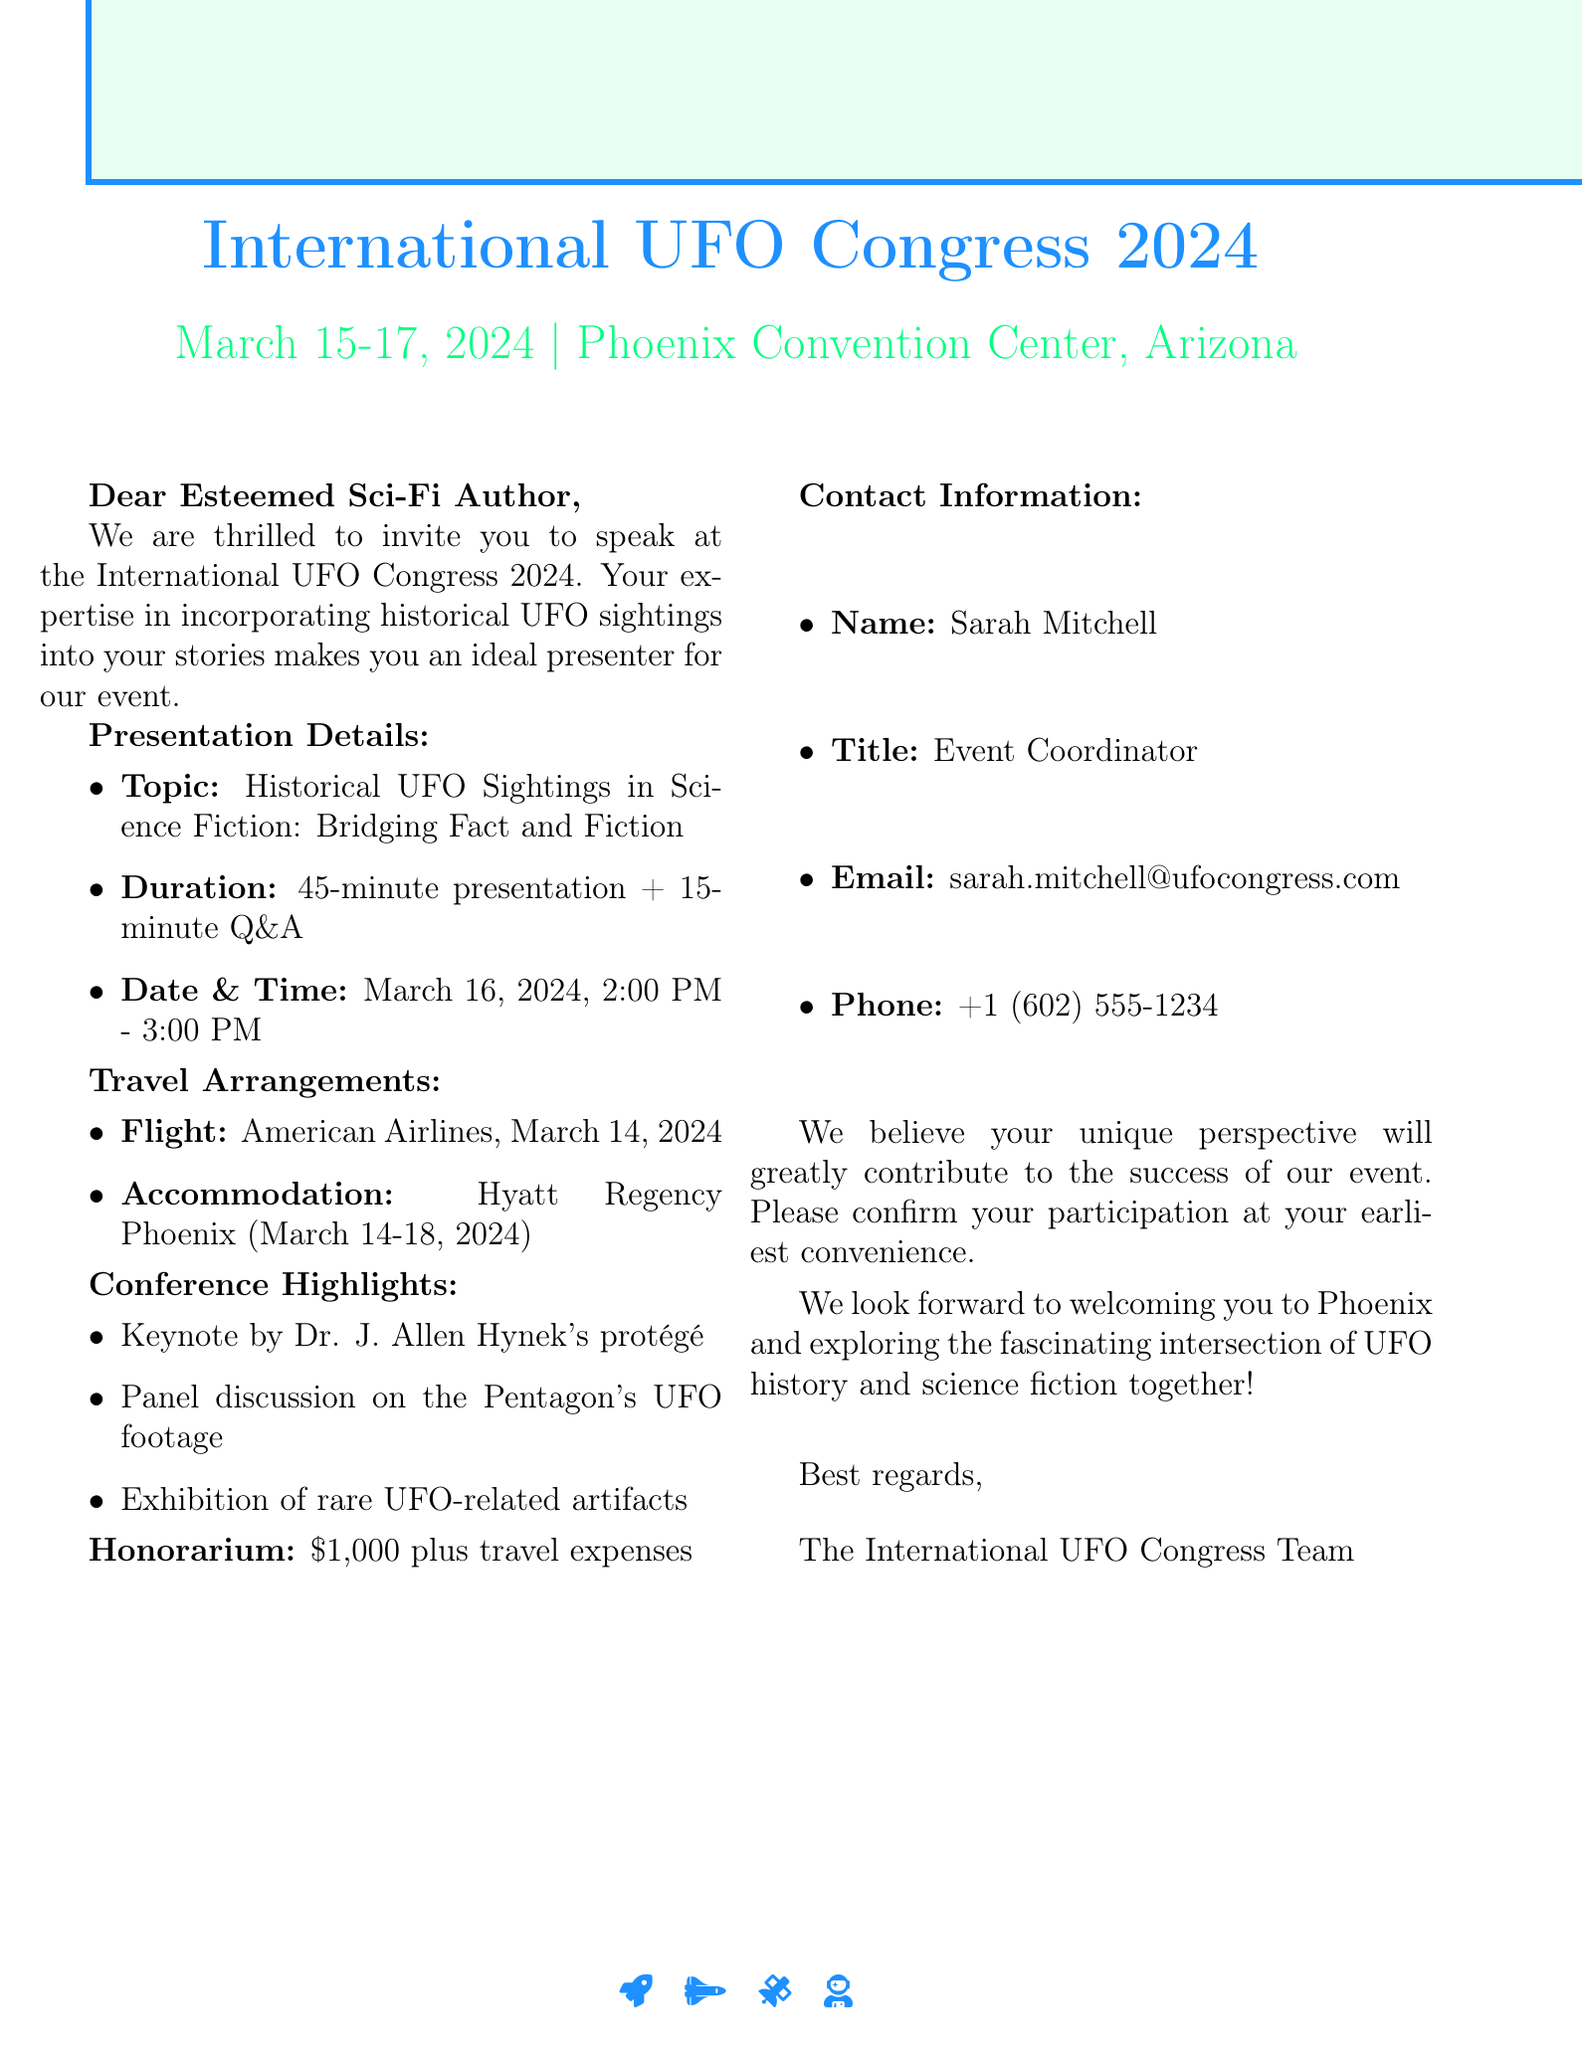What is the event name? The event name is explicitly stated in the document as "International UFO Congress 2024."
Answer: International UFO Congress 2024 What are the dates of the conference? The document provides the dates of the conference as "March 15-17, 2024."
Answer: March 15-17, 2024 Who is the contact person for the event? The document specifies that the contact person is Sarah Mitchell, along with her title and contact details.
Answer: Sarah Mitchell What is the topic of the presentation? The topic of the presentation is clearly mentioned as "Historical UFO Sightings in Science Fiction: Bridging Fact and Fiction."
Answer: Historical UFO Sightings in Science Fiction: Bridging Fact and Fiction How long is the presentation scheduled to last? The duration of the presentation is specified in the document as "45-minute presentation followed by 15-minute Q&A."
Answer: 45-minute presentation followed by 15-minute Q&A What date and time is the presentation scheduled for? The document indicates the date and time of the presentation as "March 16, 2024, 2:00 PM - 3:00 PM."
Answer: March 16, 2024, 2:00 PM - 3:00 PM What is the honorarium amount? The document states the honorarium amount as "$1,000 plus travel expenses."
Answer: $1,000 plus travel expenses What is the name of the hotel for accommodation? The document mentions that the accommodation is at "Hyatt Regency Phoenix."
Answer: Hyatt Regency Phoenix Which airline is suggested for the flight? The document specifies that "American Airlines" is the suggested airline for the flight.
Answer: American Airlines 